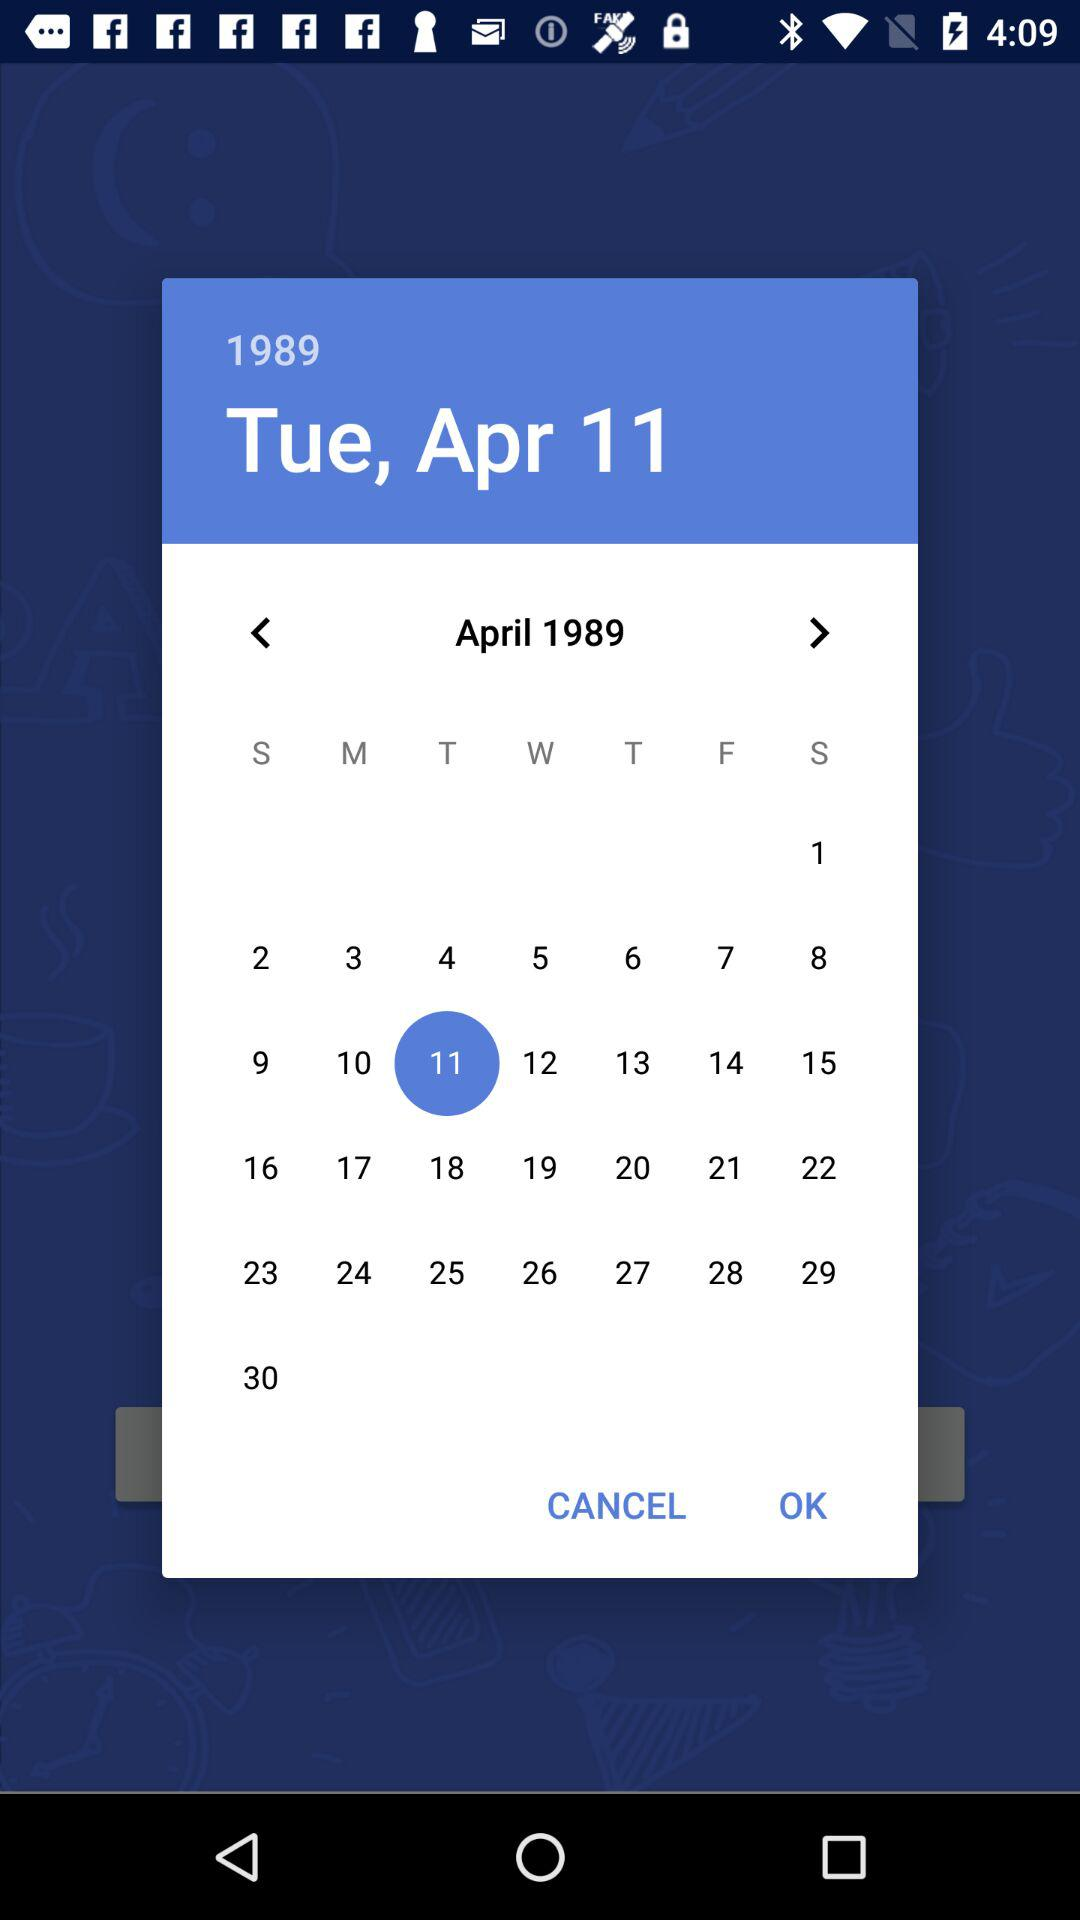What is the name of the application?
When the provided information is insufficient, respond with <no answer>. <no answer> 